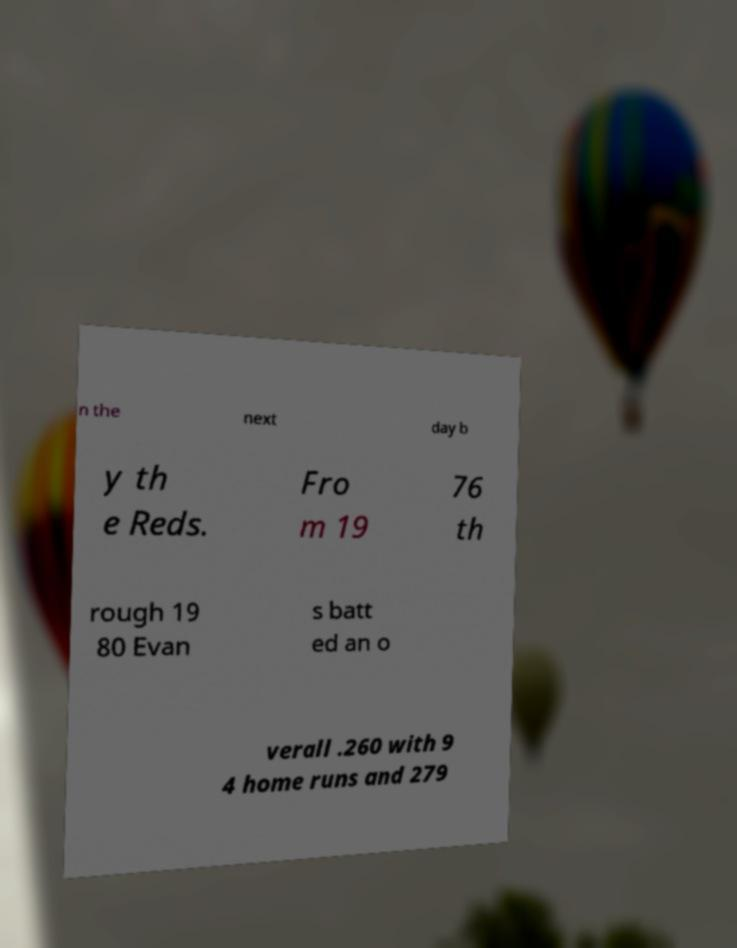Could you extract and type out the text from this image? n the next day b y th e Reds. Fro m 19 76 th rough 19 80 Evan s batt ed an o verall .260 with 9 4 home runs and 279 